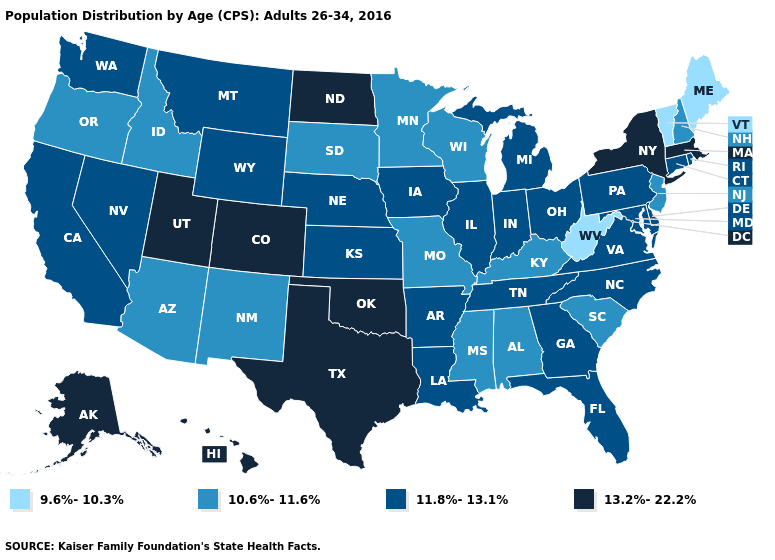What is the value of Nevada?
Short answer required. 11.8%-13.1%. Name the states that have a value in the range 11.8%-13.1%?
Write a very short answer. Arkansas, California, Connecticut, Delaware, Florida, Georgia, Illinois, Indiana, Iowa, Kansas, Louisiana, Maryland, Michigan, Montana, Nebraska, Nevada, North Carolina, Ohio, Pennsylvania, Rhode Island, Tennessee, Virginia, Washington, Wyoming. Among the states that border Colorado , does Wyoming have the highest value?
Keep it brief. No. Name the states that have a value in the range 10.6%-11.6%?
Answer briefly. Alabama, Arizona, Idaho, Kentucky, Minnesota, Mississippi, Missouri, New Hampshire, New Jersey, New Mexico, Oregon, South Carolina, South Dakota, Wisconsin. Which states have the highest value in the USA?
Quick response, please. Alaska, Colorado, Hawaii, Massachusetts, New York, North Dakota, Oklahoma, Texas, Utah. Among the states that border Kansas , does Nebraska have the highest value?
Answer briefly. No. Does the map have missing data?
Keep it brief. No. What is the value of Georgia?
Short answer required. 11.8%-13.1%. Name the states that have a value in the range 9.6%-10.3%?
Be succinct. Maine, Vermont, West Virginia. Name the states that have a value in the range 9.6%-10.3%?
Quick response, please. Maine, Vermont, West Virginia. Name the states that have a value in the range 13.2%-22.2%?
Keep it brief. Alaska, Colorado, Hawaii, Massachusetts, New York, North Dakota, Oklahoma, Texas, Utah. Name the states that have a value in the range 13.2%-22.2%?
Give a very brief answer. Alaska, Colorado, Hawaii, Massachusetts, New York, North Dakota, Oklahoma, Texas, Utah. Which states have the highest value in the USA?
Answer briefly. Alaska, Colorado, Hawaii, Massachusetts, New York, North Dakota, Oklahoma, Texas, Utah. Does Washington have the same value as Nebraska?
Be succinct. Yes. Name the states that have a value in the range 13.2%-22.2%?
Quick response, please. Alaska, Colorado, Hawaii, Massachusetts, New York, North Dakota, Oklahoma, Texas, Utah. 